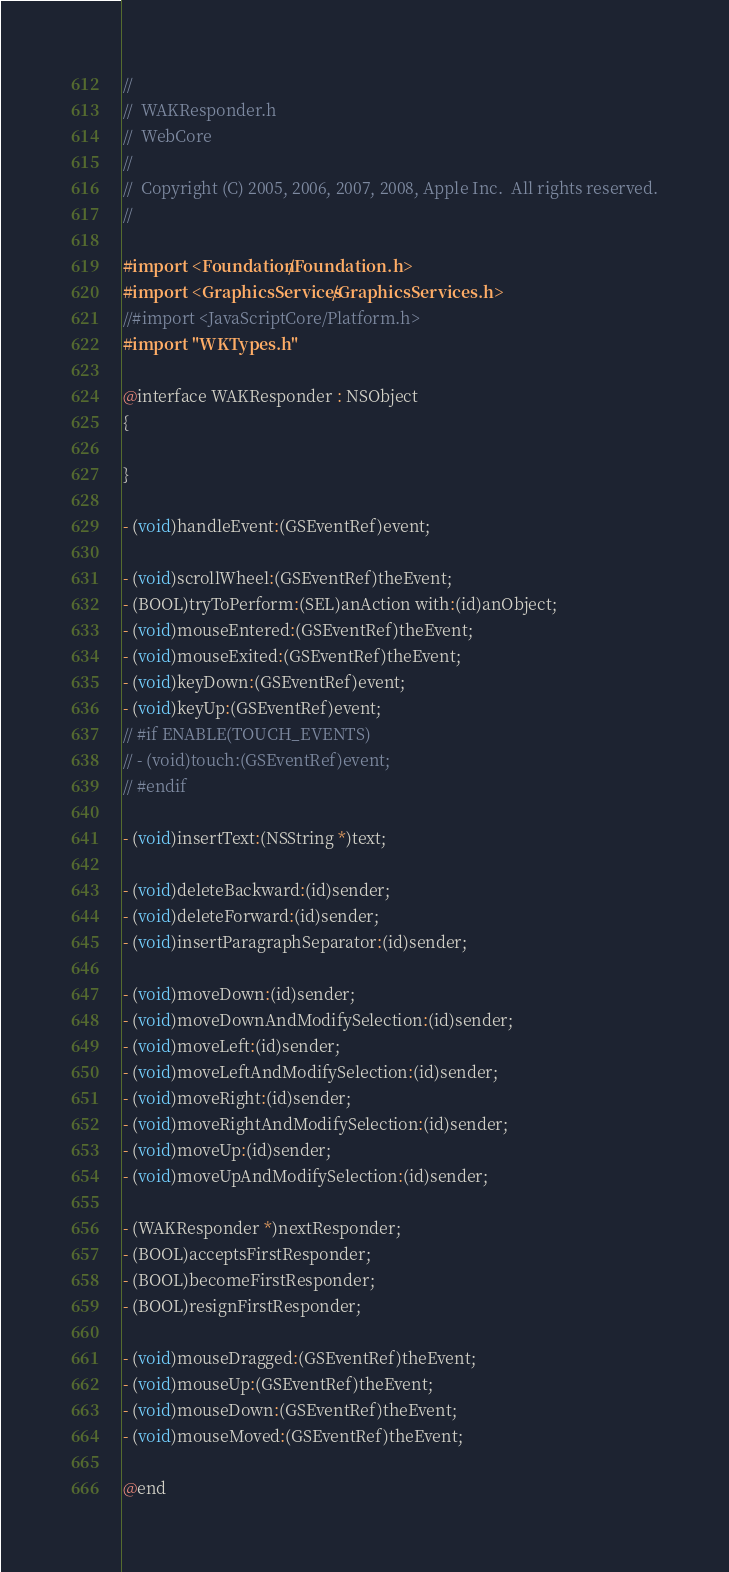Convert code to text. <code><loc_0><loc_0><loc_500><loc_500><_C_>//
//  WAKResponder.h
//  WebCore
//
//  Copyright (C) 2005, 2006, 2007, 2008, Apple Inc.  All rights reserved.
//

#import <Foundation/Foundation.h>
#import <GraphicsServices/GraphicsServices.h>
//#import <JavaScriptCore/Platform.h>
#import "WKTypes.h"

@interface WAKResponder : NSObject
{

}

- (void)handleEvent:(GSEventRef)event;

- (void)scrollWheel:(GSEventRef)theEvent;
- (BOOL)tryToPerform:(SEL)anAction with:(id)anObject;
- (void)mouseEntered:(GSEventRef)theEvent;
- (void)mouseExited:(GSEventRef)theEvent;
- (void)keyDown:(GSEventRef)event;
- (void)keyUp:(GSEventRef)event;
// #if ENABLE(TOUCH_EVENTS)
// - (void)touch:(GSEventRef)event;
// #endif

- (void)insertText:(NSString *)text;

- (void)deleteBackward:(id)sender;
- (void)deleteForward:(id)sender;
- (void)insertParagraphSeparator:(id)sender;

- (void)moveDown:(id)sender;
- (void)moveDownAndModifySelection:(id)sender;
- (void)moveLeft:(id)sender;
- (void)moveLeftAndModifySelection:(id)sender;
- (void)moveRight:(id)sender;
- (void)moveRightAndModifySelection:(id)sender;
- (void)moveUp:(id)sender;
- (void)moveUpAndModifySelection:(id)sender;

- (WAKResponder *)nextResponder;
- (BOOL)acceptsFirstResponder;
- (BOOL)becomeFirstResponder;
- (BOOL)resignFirstResponder;

- (void)mouseDragged:(GSEventRef)theEvent;
- (void)mouseUp:(GSEventRef)theEvent;
- (void)mouseDown:(GSEventRef)theEvent;
- (void)mouseMoved:(GSEventRef)theEvent;

@end
</code> 